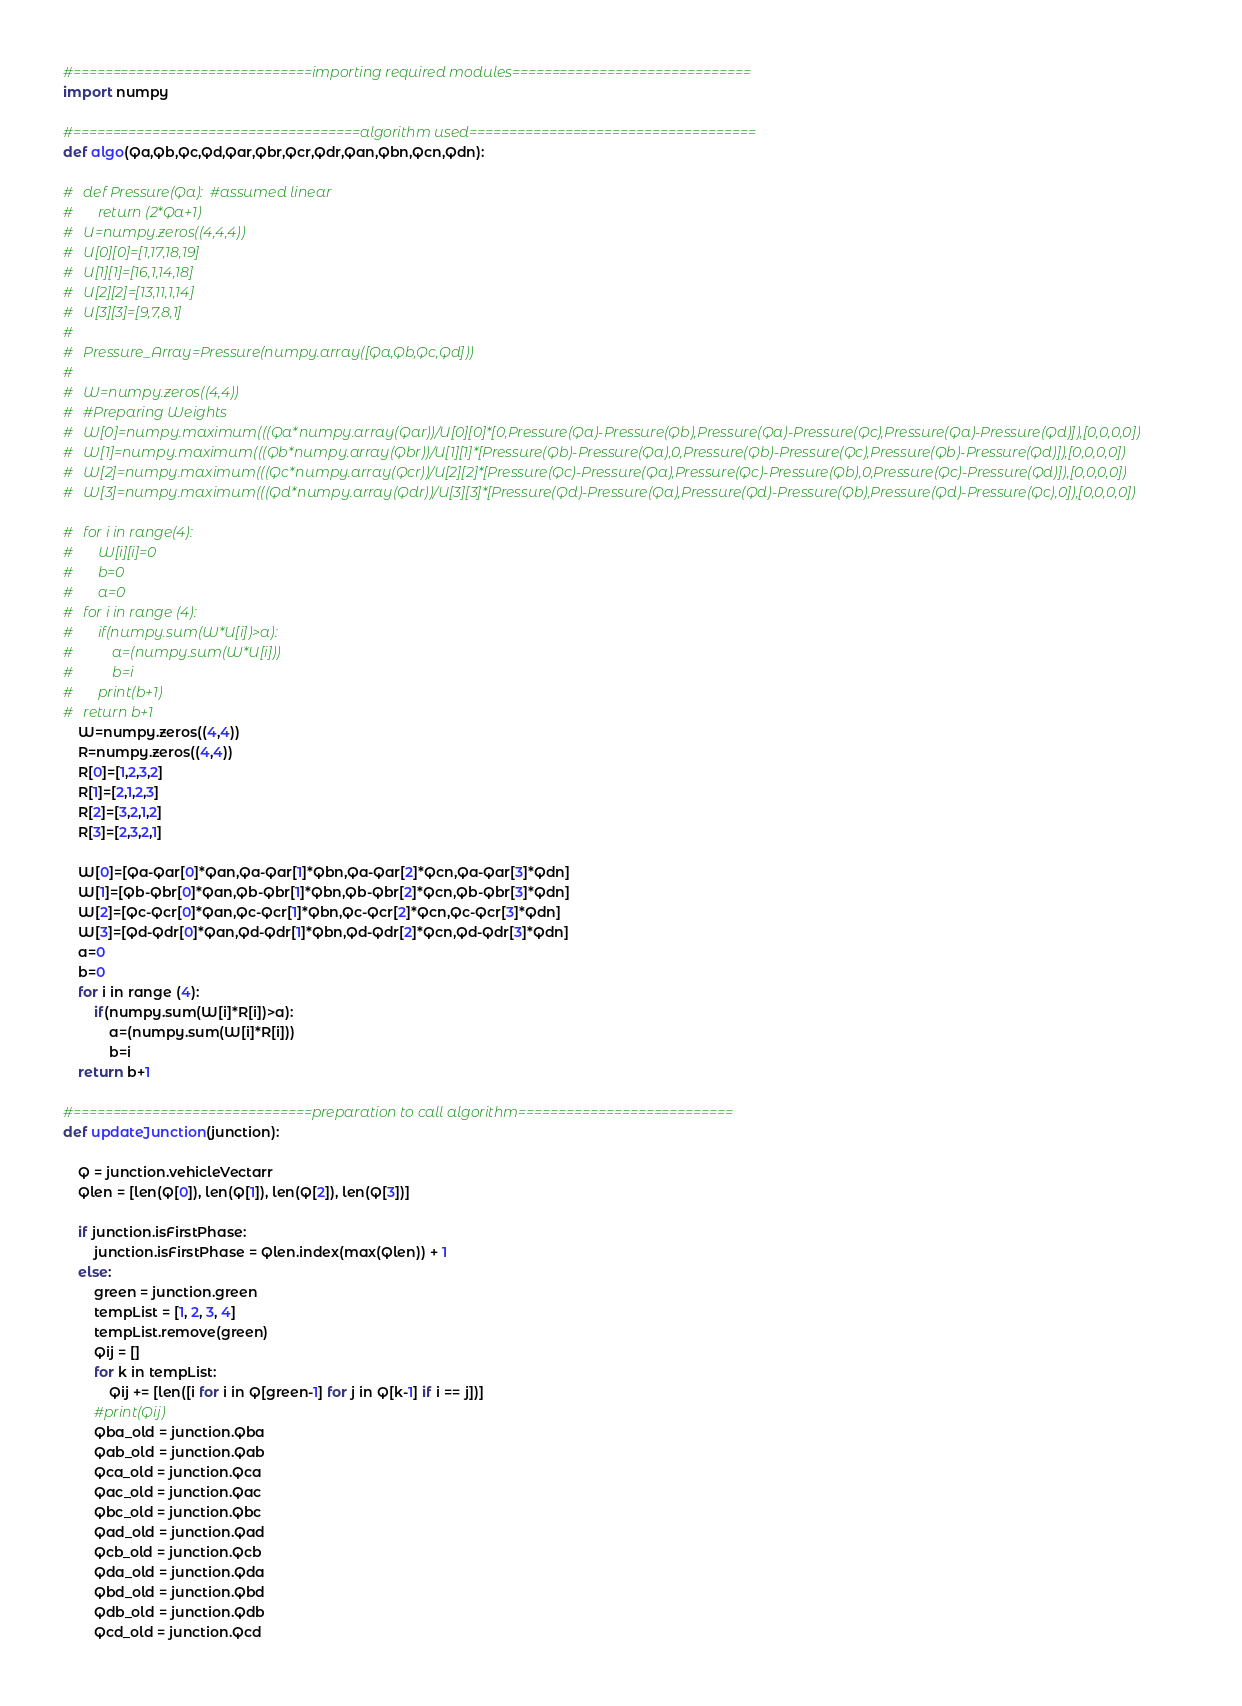Convert code to text. <code><loc_0><loc_0><loc_500><loc_500><_Python_>#==============================importing required modules==============================
import numpy

#====================================algorithm used====================================
def algo(Qa,Qb,Qc,Qd,Qar,Qbr,Qcr,Qdr,Qan,Qbn,Qcn,Qdn):
	
#	def Pressure(Qa):  #assumed linear
#		return (2*Qa+1)
#	U=numpy.zeros((4,4,4))
#	U[0][0]=[1,17,18,19]
#	U[1][1]=[16,1,14,18]
#	U[2][2]=[13,11,1,14]
#	U[3][3]=[9,7,8,1]
#
#	Pressure_Array=Pressure(numpy.array([Qa,Qb,Qc,Qd]))  
#
#	W=numpy.zeros((4,4))
#	#Preparing Weights
#	W[0]=numpy.maximum(((Qa*numpy.array(Qar))/U[0][0]*[0,Pressure(Qa)-Pressure(Qb),Pressure(Qa)-Pressure(Qc),Pressure(Qa)-Pressure(Qd)]),[0,0,0,0])
#	W[1]=numpy.maximum(((Qb*numpy.array(Qbr))/U[1][1]*[Pressure(Qb)-Pressure(Qa),0,Pressure(Qb)-Pressure(Qc),Pressure(Qb)-Pressure(Qd)]),[0,0,0,0])
#	W[2]=numpy.maximum(((Qc*numpy.array(Qcr))/U[2][2]*[Pressure(Qc)-Pressure(Qa),Pressure(Qc)-Pressure(Qb),0,Pressure(Qc)-Pressure(Qd)]),[0,0,0,0])
#	W[3]=numpy.maximum(((Qd*numpy.array(Qdr))/U[3][3]*[Pressure(Qd)-Pressure(Qa),Pressure(Qd)-Pressure(Qb),Pressure(Qd)-Pressure(Qc),0]),[0,0,0,0])
    
#	for i in range(4):
#		W[i][i]=0
#		b=0
#		a=0
#	for i in range (4):
#		if(numpy.sum(W*U[i])>a):
#			a=(numpy.sum(W*U[i]))
#			b=i
#       print(b+1)   
#	return b+1
	W=numpy.zeros((4,4))
	R=numpy.zeros((4,4))
	R[0]=[1,2,3,2]
	R[1]=[2,1,2,3]
	R[2]=[3,2,1,2]
	R[3]=[2,3,2,1]

	W[0]=[Qa-Qar[0]*Qan,Qa-Qar[1]*Qbn,Qa-Qar[2]*Qcn,Qa-Qar[3]*Qdn]
	W[1]=[Qb-Qbr[0]*Qan,Qb-Qbr[1]*Qbn,Qb-Qbr[2]*Qcn,Qb-Qbr[3]*Qdn]
	W[2]=[Qc-Qcr[0]*Qan,Qc-Qcr[1]*Qbn,Qc-Qcr[2]*Qcn,Qc-Qcr[3]*Qdn]
	W[3]=[Qd-Qdr[0]*Qan,Qd-Qdr[1]*Qbn,Qd-Qdr[2]*Qcn,Qd-Qdr[3]*Qdn]
	a=0
	b=0
	for i in range (4):
		if(numpy.sum(W[i]*R[i])>a):
			a=(numpy.sum(W[i]*R[i]))
			b=i
	return b+1

#==============================preparation to call algorithm===========================
def updateJunction(junction):
	
	Q = junction.vehicleVectarr
	Qlen = [len(Q[0]), len(Q[1]), len(Q[2]), len(Q[3])]

	if junction.isFirstPhase:
		junction.isFirstPhase = Qlen.index(max(Qlen)) + 1
	else:
		green = junction.green
		tempList = [1, 2, 3, 4]
		tempList.remove(green)
		Qij = []
		for k in tempList:
			Qij += [len([i for i in Q[green-1] for j in Q[k-1] if i == j])]
		#print(Qij)
		Qba_old = junction.Qba
		Qab_old = junction.Qab
		Qca_old = junction.Qca
		Qac_old = junction.Qac
		Qbc_old = junction.Qbc
		Qad_old = junction.Qad
		Qcb_old = junction.Qcb
		Qda_old = junction.Qda
		Qbd_old = junction.Qbd
		Qdb_old = junction.Qdb
		Qcd_old = junction.Qcd</code> 